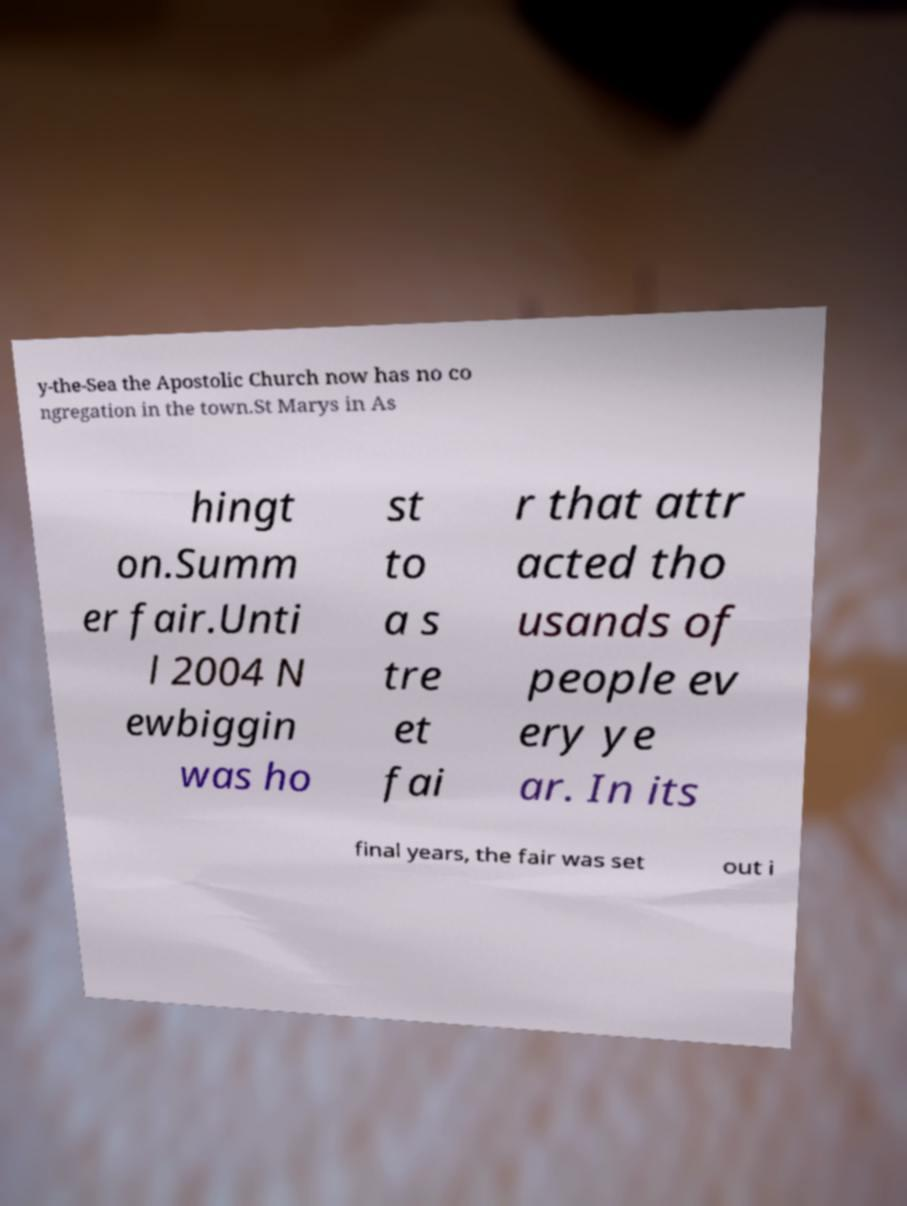What messages or text are displayed in this image? I need them in a readable, typed format. y-the-Sea the Apostolic Church now has no co ngregation in the town.St Marys in As hingt on.Summ er fair.Unti l 2004 N ewbiggin was ho st to a s tre et fai r that attr acted tho usands of people ev ery ye ar. In its final years, the fair was set out i 